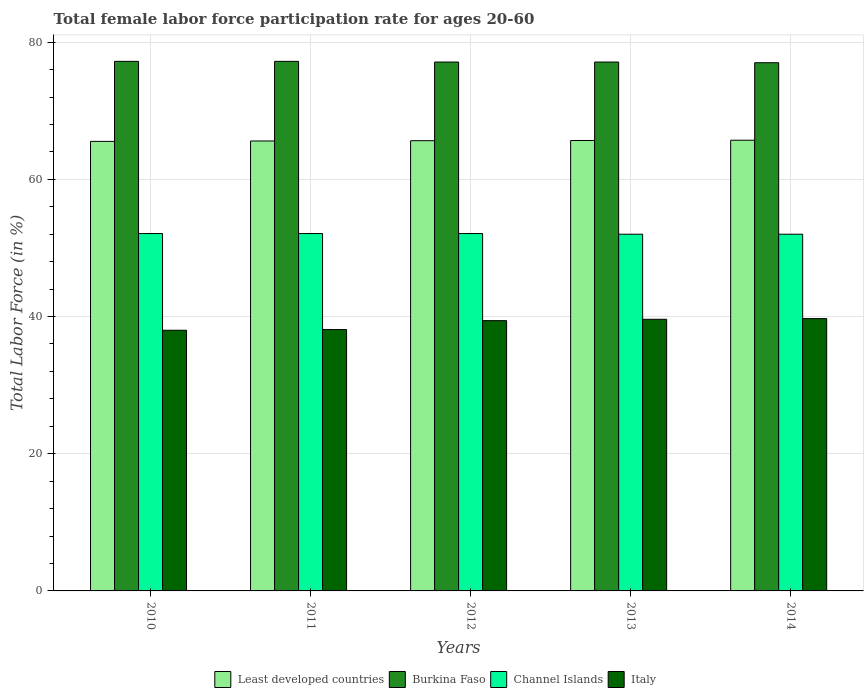How many different coloured bars are there?
Your answer should be compact. 4. How many groups of bars are there?
Provide a succinct answer. 5. In how many cases, is the number of bars for a given year not equal to the number of legend labels?
Your answer should be compact. 0. What is the female labor force participation rate in Italy in 2012?
Your answer should be compact. 39.4. Across all years, what is the maximum female labor force participation rate in Burkina Faso?
Ensure brevity in your answer.  77.2. What is the total female labor force participation rate in Italy in the graph?
Provide a succinct answer. 194.8. What is the difference between the female labor force participation rate in Least developed countries in 2010 and that in 2011?
Make the answer very short. -0.06. What is the difference between the female labor force participation rate in Burkina Faso in 2010 and the female labor force participation rate in Least developed countries in 2013?
Your answer should be very brief. 11.54. What is the average female labor force participation rate in Least developed countries per year?
Provide a short and direct response. 65.63. In the year 2014, what is the difference between the female labor force participation rate in Least developed countries and female labor force participation rate in Italy?
Make the answer very short. 26. In how many years, is the female labor force participation rate in Channel Islands greater than 40 %?
Your answer should be compact. 5. What is the ratio of the female labor force participation rate in Least developed countries in 2011 to that in 2013?
Keep it short and to the point. 1. Is the difference between the female labor force participation rate in Least developed countries in 2011 and 2014 greater than the difference between the female labor force participation rate in Italy in 2011 and 2014?
Your answer should be very brief. Yes. What is the difference between the highest and the second highest female labor force participation rate in Burkina Faso?
Offer a very short reply. 0. What is the difference between the highest and the lowest female labor force participation rate in Least developed countries?
Ensure brevity in your answer.  0.17. In how many years, is the female labor force participation rate in Channel Islands greater than the average female labor force participation rate in Channel Islands taken over all years?
Provide a succinct answer. 3. Is the sum of the female labor force participation rate in Least developed countries in 2010 and 2013 greater than the maximum female labor force participation rate in Channel Islands across all years?
Give a very brief answer. Yes. What does the 3rd bar from the left in 2014 represents?
Give a very brief answer. Channel Islands. What does the 4th bar from the right in 2011 represents?
Keep it short and to the point. Least developed countries. Is it the case that in every year, the sum of the female labor force participation rate in Burkina Faso and female labor force participation rate in Least developed countries is greater than the female labor force participation rate in Italy?
Provide a short and direct response. Yes. How many bars are there?
Keep it short and to the point. 20. Are the values on the major ticks of Y-axis written in scientific E-notation?
Give a very brief answer. No. Does the graph contain any zero values?
Your answer should be very brief. No. Where does the legend appear in the graph?
Your response must be concise. Bottom center. How many legend labels are there?
Your answer should be compact. 4. What is the title of the graph?
Your answer should be compact. Total female labor force participation rate for ages 20-60. What is the Total Labor Force (in %) of Least developed countries in 2010?
Offer a very short reply. 65.53. What is the Total Labor Force (in %) in Burkina Faso in 2010?
Your response must be concise. 77.2. What is the Total Labor Force (in %) of Channel Islands in 2010?
Your answer should be very brief. 52.1. What is the Total Labor Force (in %) in Italy in 2010?
Your answer should be very brief. 38. What is the Total Labor Force (in %) in Least developed countries in 2011?
Keep it short and to the point. 65.59. What is the Total Labor Force (in %) in Burkina Faso in 2011?
Your response must be concise. 77.2. What is the Total Labor Force (in %) of Channel Islands in 2011?
Your answer should be very brief. 52.1. What is the Total Labor Force (in %) in Italy in 2011?
Make the answer very short. 38.1. What is the Total Labor Force (in %) in Least developed countries in 2012?
Ensure brevity in your answer.  65.63. What is the Total Labor Force (in %) of Burkina Faso in 2012?
Offer a terse response. 77.1. What is the Total Labor Force (in %) in Channel Islands in 2012?
Your answer should be compact. 52.1. What is the Total Labor Force (in %) of Italy in 2012?
Your response must be concise. 39.4. What is the Total Labor Force (in %) of Least developed countries in 2013?
Ensure brevity in your answer.  65.66. What is the Total Labor Force (in %) in Burkina Faso in 2013?
Offer a terse response. 77.1. What is the Total Labor Force (in %) in Channel Islands in 2013?
Ensure brevity in your answer.  52. What is the Total Labor Force (in %) in Italy in 2013?
Provide a succinct answer. 39.6. What is the Total Labor Force (in %) in Least developed countries in 2014?
Your answer should be very brief. 65.7. What is the Total Labor Force (in %) in Burkina Faso in 2014?
Give a very brief answer. 77. What is the Total Labor Force (in %) in Italy in 2014?
Your answer should be compact. 39.7. Across all years, what is the maximum Total Labor Force (in %) of Least developed countries?
Offer a very short reply. 65.7. Across all years, what is the maximum Total Labor Force (in %) in Burkina Faso?
Offer a terse response. 77.2. Across all years, what is the maximum Total Labor Force (in %) in Channel Islands?
Ensure brevity in your answer.  52.1. Across all years, what is the maximum Total Labor Force (in %) of Italy?
Offer a terse response. 39.7. Across all years, what is the minimum Total Labor Force (in %) in Least developed countries?
Offer a terse response. 65.53. Across all years, what is the minimum Total Labor Force (in %) of Italy?
Offer a very short reply. 38. What is the total Total Labor Force (in %) of Least developed countries in the graph?
Offer a terse response. 328.13. What is the total Total Labor Force (in %) of Burkina Faso in the graph?
Your response must be concise. 385.6. What is the total Total Labor Force (in %) in Channel Islands in the graph?
Ensure brevity in your answer.  260.3. What is the total Total Labor Force (in %) of Italy in the graph?
Give a very brief answer. 194.8. What is the difference between the Total Labor Force (in %) of Least developed countries in 2010 and that in 2011?
Your answer should be very brief. -0.06. What is the difference between the Total Labor Force (in %) in Italy in 2010 and that in 2011?
Give a very brief answer. -0.1. What is the difference between the Total Labor Force (in %) of Least developed countries in 2010 and that in 2012?
Provide a succinct answer. -0.1. What is the difference between the Total Labor Force (in %) in Burkina Faso in 2010 and that in 2012?
Offer a very short reply. 0.1. What is the difference between the Total Labor Force (in %) in Least developed countries in 2010 and that in 2013?
Your answer should be very brief. -0.13. What is the difference between the Total Labor Force (in %) of Burkina Faso in 2010 and that in 2013?
Provide a succinct answer. 0.1. What is the difference between the Total Labor Force (in %) of Channel Islands in 2010 and that in 2013?
Your response must be concise. 0.1. What is the difference between the Total Labor Force (in %) in Italy in 2010 and that in 2013?
Offer a very short reply. -1.6. What is the difference between the Total Labor Force (in %) of Least developed countries in 2010 and that in 2014?
Offer a terse response. -0.17. What is the difference between the Total Labor Force (in %) of Burkina Faso in 2010 and that in 2014?
Ensure brevity in your answer.  0.2. What is the difference between the Total Labor Force (in %) in Least developed countries in 2011 and that in 2012?
Ensure brevity in your answer.  -0.04. What is the difference between the Total Labor Force (in %) in Channel Islands in 2011 and that in 2012?
Provide a succinct answer. 0. What is the difference between the Total Labor Force (in %) in Italy in 2011 and that in 2012?
Your answer should be compact. -1.3. What is the difference between the Total Labor Force (in %) of Least developed countries in 2011 and that in 2013?
Ensure brevity in your answer.  -0.07. What is the difference between the Total Labor Force (in %) of Burkina Faso in 2011 and that in 2013?
Ensure brevity in your answer.  0.1. What is the difference between the Total Labor Force (in %) of Italy in 2011 and that in 2013?
Provide a short and direct response. -1.5. What is the difference between the Total Labor Force (in %) of Least developed countries in 2011 and that in 2014?
Your answer should be compact. -0.11. What is the difference between the Total Labor Force (in %) of Burkina Faso in 2011 and that in 2014?
Give a very brief answer. 0.2. What is the difference between the Total Labor Force (in %) of Least developed countries in 2012 and that in 2013?
Keep it short and to the point. -0.03. What is the difference between the Total Labor Force (in %) of Burkina Faso in 2012 and that in 2013?
Provide a succinct answer. 0. What is the difference between the Total Labor Force (in %) of Least developed countries in 2012 and that in 2014?
Give a very brief answer. -0.07. What is the difference between the Total Labor Force (in %) of Channel Islands in 2012 and that in 2014?
Your answer should be very brief. 0.1. What is the difference between the Total Labor Force (in %) of Italy in 2012 and that in 2014?
Offer a terse response. -0.3. What is the difference between the Total Labor Force (in %) in Least developed countries in 2013 and that in 2014?
Make the answer very short. -0.04. What is the difference between the Total Labor Force (in %) of Burkina Faso in 2013 and that in 2014?
Make the answer very short. 0.1. What is the difference between the Total Labor Force (in %) in Italy in 2013 and that in 2014?
Provide a succinct answer. -0.1. What is the difference between the Total Labor Force (in %) of Least developed countries in 2010 and the Total Labor Force (in %) of Burkina Faso in 2011?
Give a very brief answer. -11.67. What is the difference between the Total Labor Force (in %) of Least developed countries in 2010 and the Total Labor Force (in %) of Channel Islands in 2011?
Offer a very short reply. 13.43. What is the difference between the Total Labor Force (in %) of Least developed countries in 2010 and the Total Labor Force (in %) of Italy in 2011?
Your answer should be compact. 27.43. What is the difference between the Total Labor Force (in %) in Burkina Faso in 2010 and the Total Labor Force (in %) in Channel Islands in 2011?
Give a very brief answer. 25.1. What is the difference between the Total Labor Force (in %) of Burkina Faso in 2010 and the Total Labor Force (in %) of Italy in 2011?
Give a very brief answer. 39.1. What is the difference between the Total Labor Force (in %) in Least developed countries in 2010 and the Total Labor Force (in %) in Burkina Faso in 2012?
Make the answer very short. -11.57. What is the difference between the Total Labor Force (in %) in Least developed countries in 2010 and the Total Labor Force (in %) in Channel Islands in 2012?
Ensure brevity in your answer.  13.43. What is the difference between the Total Labor Force (in %) of Least developed countries in 2010 and the Total Labor Force (in %) of Italy in 2012?
Ensure brevity in your answer.  26.13. What is the difference between the Total Labor Force (in %) in Burkina Faso in 2010 and the Total Labor Force (in %) in Channel Islands in 2012?
Provide a short and direct response. 25.1. What is the difference between the Total Labor Force (in %) in Burkina Faso in 2010 and the Total Labor Force (in %) in Italy in 2012?
Make the answer very short. 37.8. What is the difference between the Total Labor Force (in %) of Least developed countries in 2010 and the Total Labor Force (in %) of Burkina Faso in 2013?
Your answer should be very brief. -11.57. What is the difference between the Total Labor Force (in %) in Least developed countries in 2010 and the Total Labor Force (in %) in Channel Islands in 2013?
Offer a terse response. 13.53. What is the difference between the Total Labor Force (in %) in Least developed countries in 2010 and the Total Labor Force (in %) in Italy in 2013?
Offer a very short reply. 25.93. What is the difference between the Total Labor Force (in %) of Burkina Faso in 2010 and the Total Labor Force (in %) of Channel Islands in 2013?
Offer a very short reply. 25.2. What is the difference between the Total Labor Force (in %) of Burkina Faso in 2010 and the Total Labor Force (in %) of Italy in 2013?
Provide a short and direct response. 37.6. What is the difference between the Total Labor Force (in %) of Least developed countries in 2010 and the Total Labor Force (in %) of Burkina Faso in 2014?
Your response must be concise. -11.47. What is the difference between the Total Labor Force (in %) of Least developed countries in 2010 and the Total Labor Force (in %) of Channel Islands in 2014?
Your response must be concise. 13.53. What is the difference between the Total Labor Force (in %) in Least developed countries in 2010 and the Total Labor Force (in %) in Italy in 2014?
Offer a very short reply. 25.83. What is the difference between the Total Labor Force (in %) in Burkina Faso in 2010 and the Total Labor Force (in %) in Channel Islands in 2014?
Provide a short and direct response. 25.2. What is the difference between the Total Labor Force (in %) in Burkina Faso in 2010 and the Total Labor Force (in %) in Italy in 2014?
Make the answer very short. 37.5. What is the difference between the Total Labor Force (in %) in Least developed countries in 2011 and the Total Labor Force (in %) in Burkina Faso in 2012?
Provide a succinct answer. -11.51. What is the difference between the Total Labor Force (in %) of Least developed countries in 2011 and the Total Labor Force (in %) of Channel Islands in 2012?
Your answer should be very brief. 13.49. What is the difference between the Total Labor Force (in %) of Least developed countries in 2011 and the Total Labor Force (in %) of Italy in 2012?
Give a very brief answer. 26.19. What is the difference between the Total Labor Force (in %) of Burkina Faso in 2011 and the Total Labor Force (in %) of Channel Islands in 2012?
Give a very brief answer. 25.1. What is the difference between the Total Labor Force (in %) in Burkina Faso in 2011 and the Total Labor Force (in %) in Italy in 2012?
Your response must be concise. 37.8. What is the difference between the Total Labor Force (in %) of Channel Islands in 2011 and the Total Labor Force (in %) of Italy in 2012?
Offer a very short reply. 12.7. What is the difference between the Total Labor Force (in %) of Least developed countries in 2011 and the Total Labor Force (in %) of Burkina Faso in 2013?
Provide a short and direct response. -11.51. What is the difference between the Total Labor Force (in %) of Least developed countries in 2011 and the Total Labor Force (in %) of Channel Islands in 2013?
Your answer should be compact. 13.59. What is the difference between the Total Labor Force (in %) in Least developed countries in 2011 and the Total Labor Force (in %) in Italy in 2013?
Your answer should be compact. 25.99. What is the difference between the Total Labor Force (in %) in Burkina Faso in 2011 and the Total Labor Force (in %) in Channel Islands in 2013?
Your response must be concise. 25.2. What is the difference between the Total Labor Force (in %) in Burkina Faso in 2011 and the Total Labor Force (in %) in Italy in 2013?
Your response must be concise. 37.6. What is the difference between the Total Labor Force (in %) of Least developed countries in 2011 and the Total Labor Force (in %) of Burkina Faso in 2014?
Provide a succinct answer. -11.41. What is the difference between the Total Labor Force (in %) in Least developed countries in 2011 and the Total Labor Force (in %) in Channel Islands in 2014?
Make the answer very short. 13.59. What is the difference between the Total Labor Force (in %) in Least developed countries in 2011 and the Total Labor Force (in %) in Italy in 2014?
Give a very brief answer. 25.89. What is the difference between the Total Labor Force (in %) in Burkina Faso in 2011 and the Total Labor Force (in %) in Channel Islands in 2014?
Offer a very short reply. 25.2. What is the difference between the Total Labor Force (in %) in Burkina Faso in 2011 and the Total Labor Force (in %) in Italy in 2014?
Provide a short and direct response. 37.5. What is the difference between the Total Labor Force (in %) in Least developed countries in 2012 and the Total Labor Force (in %) in Burkina Faso in 2013?
Ensure brevity in your answer.  -11.47. What is the difference between the Total Labor Force (in %) in Least developed countries in 2012 and the Total Labor Force (in %) in Channel Islands in 2013?
Your answer should be compact. 13.63. What is the difference between the Total Labor Force (in %) of Least developed countries in 2012 and the Total Labor Force (in %) of Italy in 2013?
Give a very brief answer. 26.03. What is the difference between the Total Labor Force (in %) in Burkina Faso in 2012 and the Total Labor Force (in %) in Channel Islands in 2013?
Offer a terse response. 25.1. What is the difference between the Total Labor Force (in %) in Burkina Faso in 2012 and the Total Labor Force (in %) in Italy in 2013?
Your answer should be very brief. 37.5. What is the difference between the Total Labor Force (in %) of Channel Islands in 2012 and the Total Labor Force (in %) of Italy in 2013?
Give a very brief answer. 12.5. What is the difference between the Total Labor Force (in %) in Least developed countries in 2012 and the Total Labor Force (in %) in Burkina Faso in 2014?
Your answer should be compact. -11.37. What is the difference between the Total Labor Force (in %) of Least developed countries in 2012 and the Total Labor Force (in %) of Channel Islands in 2014?
Offer a very short reply. 13.63. What is the difference between the Total Labor Force (in %) of Least developed countries in 2012 and the Total Labor Force (in %) of Italy in 2014?
Ensure brevity in your answer.  25.93. What is the difference between the Total Labor Force (in %) of Burkina Faso in 2012 and the Total Labor Force (in %) of Channel Islands in 2014?
Provide a short and direct response. 25.1. What is the difference between the Total Labor Force (in %) in Burkina Faso in 2012 and the Total Labor Force (in %) in Italy in 2014?
Provide a short and direct response. 37.4. What is the difference between the Total Labor Force (in %) of Least developed countries in 2013 and the Total Labor Force (in %) of Burkina Faso in 2014?
Make the answer very short. -11.34. What is the difference between the Total Labor Force (in %) in Least developed countries in 2013 and the Total Labor Force (in %) in Channel Islands in 2014?
Your answer should be very brief. 13.66. What is the difference between the Total Labor Force (in %) in Least developed countries in 2013 and the Total Labor Force (in %) in Italy in 2014?
Keep it short and to the point. 25.96. What is the difference between the Total Labor Force (in %) of Burkina Faso in 2013 and the Total Labor Force (in %) of Channel Islands in 2014?
Make the answer very short. 25.1. What is the difference between the Total Labor Force (in %) of Burkina Faso in 2013 and the Total Labor Force (in %) of Italy in 2014?
Provide a succinct answer. 37.4. What is the average Total Labor Force (in %) in Least developed countries per year?
Ensure brevity in your answer.  65.63. What is the average Total Labor Force (in %) of Burkina Faso per year?
Offer a very short reply. 77.12. What is the average Total Labor Force (in %) in Channel Islands per year?
Make the answer very short. 52.06. What is the average Total Labor Force (in %) of Italy per year?
Give a very brief answer. 38.96. In the year 2010, what is the difference between the Total Labor Force (in %) of Least developed countries and Total Labor Force (in %) of Burkina Faso?
Offer a very short reply. -11.67. In the year 2010, what is the difference between the Total Labor Force (in %) in Least developed countries and Total Labor Force (in %) in Channel Islands?
Offer a terse response. 13.43. In the year 2010, what is the difference between the Total Labor Force (in %) of Least developed countries and Total Labor Force (in %) of Italy?
Provide a short and direct response. 27.53. In the year 2010, what is the difference between the Total Labor Force (in %) of Burkina Faso and Total Labor Force (in %) of Channel Islands?
Make the answer very short. 25.1. In the year 2010, what is the difference between the Total Labor Force (in %) of Burkina Faso and Total Labor Force (in %) of Italy?
Offer a very short reply. 39.2. In the year 2011, what is the difference between the Total Labor Force (in %) of Least developed countries and Total Labor Force (in %) of Burkina Faso?
Your answer should be very brief. -11.61. In the year 2011, what is the difference between the Total Labor Force (in %) in Least developed countries and Total Labor Force (in %) in Channel Islands?
Provide a succinct answer. 13.49. In the year 2011, what is the difference between the Total Labor Force (in %) in Least developed countries and Total Labor Force (in %) in Italy?
Offer a terse response. 27.49. In the year 2011, what is the difference between the Total Labor Force (in %) of Burkina Faso and Total Labor Force (in %) of Channel Islands?
Your response must be concise. 25.1. In the year 2011, what is the difference between the Total Labor Force (in %) in Burkina Faso and Total Labor Force (in %) in Italy?
Your response must be concise. 39.1. In the year 2011, what is the difference between the Total Labor Force (in %) of Channel Islands and Total Labor Force (in %) of Italy?
Keep it short and to the point. 14. In the year 2012, what is the difference between the Total Labor Force (in %) of Least developed countries and Total Labor Force (in %) of Burkina Faso?
Provide a succinct answer. -11.47. In the year 2012, what is the difference between the Total Labor Force (in %) of Least developed countries and Total Labor Force (in %) of Channel Islands?
Provide a succinct answer. 13.53. In the year 2012, what is the difference between the Total Labor Force (in %) of Least developed countries and Total Labor Force (in %) of Italy?
Give a very brief answer. 26.23. In the year 2012, what is the difference between the Total Labor Force (in %) of Burkina Faso and Total Labor Force (in %) of Italy?
Give a very brief answer. 37.7. In the year 2012, what is the difference between the Total Labor Force (in %) in Channel Islands and Total Labor Force (in %) in Italy?
Your answer should be very brief. 12.7. In the year 2013, what is the difference between the Total Labor Force (in %) of Least developed countries and Total Labor Force (in %) of Burkina Faso?
Your answer should be compact. -11.44. In the year 2013, what is the difference between the Total Labor Force (in %) of Least developed countries and Total Labor Force (in %) of Channel Islands?
Offer a terse response. 13.66. In the year 2013, what is the difference between the Total Labor Force (in %) in Least developed countries and Total Labor Force (in %) in Italy?
Your answer should be compact. 26.06. In the year 2013, what is the difference between the Total Labor Force (in %) of Burkina Faso and Total Labor Force (in %) of Channel Islands?
Provide a short and direct response. 25.1. In the year 2013, what is the difference between the Total Labor Force (in %) in Burkina Faso and Total Labor Force (in %) in Italy?
Provide a short and direct response. 37.5. In the year 2014, what is the difference between the Total Labor Force (in %) in Least developed countries and Total Labor Force (in %) in Burkina Faso?
Provide a succinct answer. -11.3. In the year 2014, what is the difference between the Total Labor Force (in %) of Least developed countries and Total Labor Force (in %) of Channel Islands?
Provide a short and direct response. 13.7. In the year 2014, what is the difference between the Total Labor Force (in %) of Least developed countries and Total Labor Force (in %) of Italy?
Provide a short and direct response. 26. In the year 2014, what is the difference between the Total Labor Force (in %) in Burkina Faso and Total Labor Force (in %) in Italy?
Your response must be concise. 37.3. In the year 2014, what is the difference between the Total Labor Force (in %) of Channel Islands and Total Labor Force (in %) of Italy?
Keep it short and to the point. 12.3. What is the ratio of the Total Labor Force (in %) in Least developed countries in 2010 to that in 2011?
Provide a short and direct response. 1. What is the ratio of the Total Labor Force (in %) of Channel Islands in 2010 to that in 2011?
Provide a succinct answer. 1. What is the ratio of the Total Labor Force (in %) of Italy in 2010 to that in 2011?
Keep it short and to the point. 1. What is the ratio of the Total Labor Force (in %) in Least developed countries in 2010 to that in 2012?
Offer a very short reply. 1. What is the ratio of the Total Labor Force (in %) of Italy in 2010 to that in 2012?
Provide a succinct answer. 0.96. What is the ratio of the Total Labor Force (in %) in Least developed countries in 2010 to that in 2013?
Keep it short and to the point. 1. What is the ratio of the Total Labor Force (in %) of Italy in 2010 to that in 2013?
Your answer should be very brief. 0.96. What is the ratio of the Total Labor Force (in %) of Least developed countries in 2010 to that in 2014?
Your answer should be compact. 1. What is the ratio of the Total Labor Force (in %) in Burkina Faso in 2010 to that in 2014?
Your answer should be very brief. 1. What is the ratio of the Total Labor Force (in %) in Channel Islands in 2010 to that in 2014?
Provide a succinct answer. 1. What is the ratio of the Total Labor Force (in %) of Italy in 2010 to that in 2014?
Your response must be concise. 0.96. What is the ratio of the Total Labor Force (in %) of Channel Islands in 2011 to that in 2012?
Provide a short and direct response. 1. What is the ratio of the Total Labor Force (in %) of Italy in 2011 to that in 2012?
Keep it short and to the point. 0.97. What is the ratio of the Total Labor Force (in %) in Burkina Faso in 2011 to that in 2013?
Your answer should be compact. 1. What is the ratio of the Total Labor Force (in %) in Channel Islands in 2011 to that in 2013?
Your answer should be compact. 1. What is the ratio of the Total Labor Force (in %) in Italy in 2011 to that in 2013?
Keep it short and to the point. 0.96. What is the ratio of the Total Labor Force (in %) in Least developed countries in 2011 to that in 2014?
Ensure brevity in your answer.  1. What is the ratio of the Total Labor Force (in %) of Italy in 2011 to that in 2014?
Ensure brevity in your answer.  0.96. What is the ratio of the Total Labor Force (in %) in Burkina Faso in 2012 to that in 2013?
Keep it short and to the point. 1. What is the ratio of the Total Labor Force (in %) of Italy in 2012 to that in 2013?
Keep it short and to the point. 0.99. What is the ratio of the Total Labor Force (in %) of Channel Islands in 2012 to that in 2014?
Ensure brevity in your answer.  1. What is the difference between the highest and the second highest Total Labor Force (in %) in Least developed countries?
Make the answer very short. 0.04. What is the difference between the highest and the second highest Total Labor Force (in %) of Italy?
Ensure brevity in your answer.  0.1. What is the difference between the highest and the lowest Total Labor Force (in %) in Least developed countries?
Offer a very short reply. 0.17. What is the difference between the highest and the lowest Total Labor Force (in %) of Channel Islands?
Your response must be concise. 0.1. 